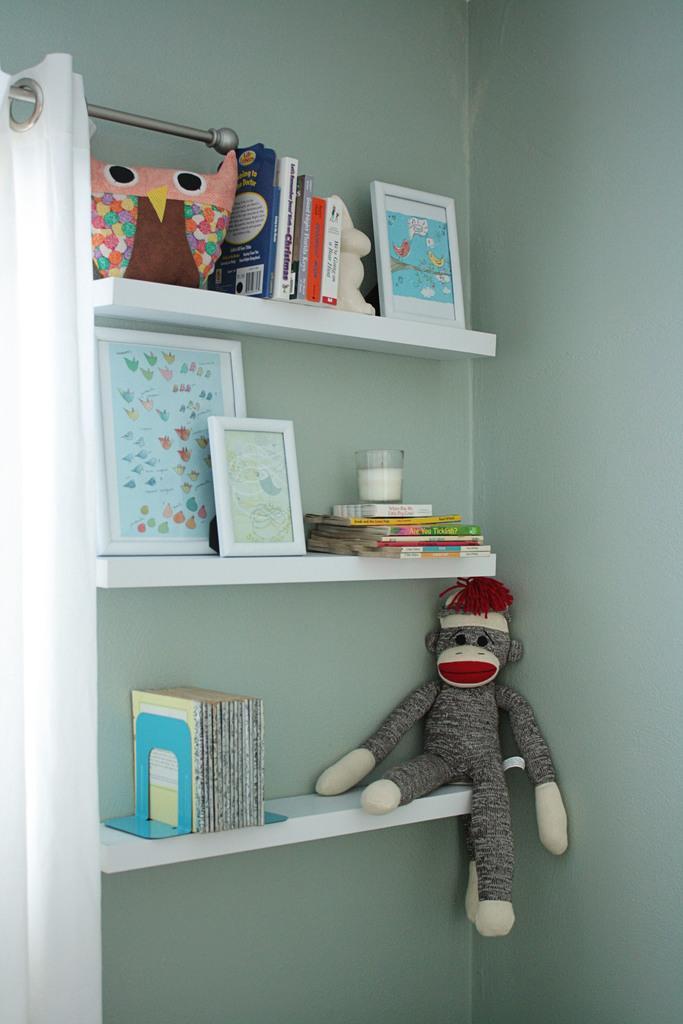Could you give a brief overview of what you see in this image? In this image we can see few books, picture frames, a doll and few objects on the shelves and a curtain to the rod on the left side of the image. 